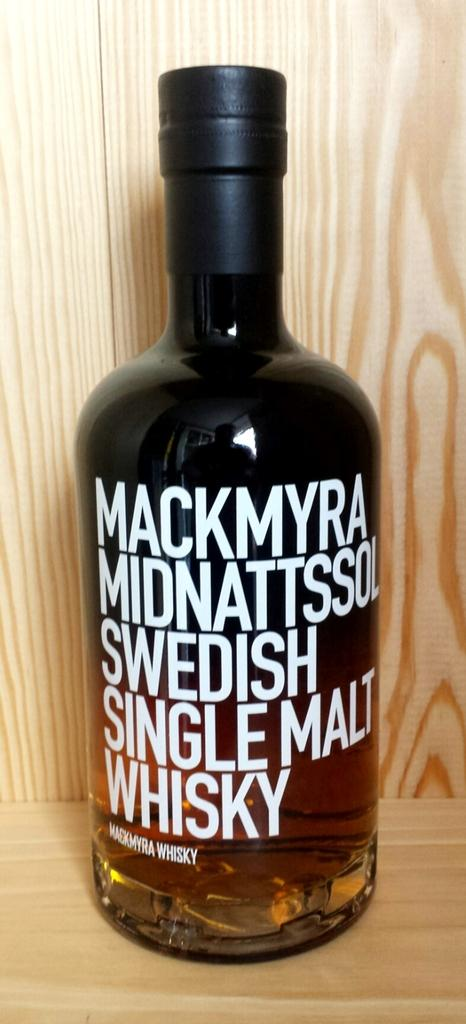<image>
Present a compact description of the photo's key features. A bottle of Mackmyra Midnattssol Swedish Single Malt Whiskey. 